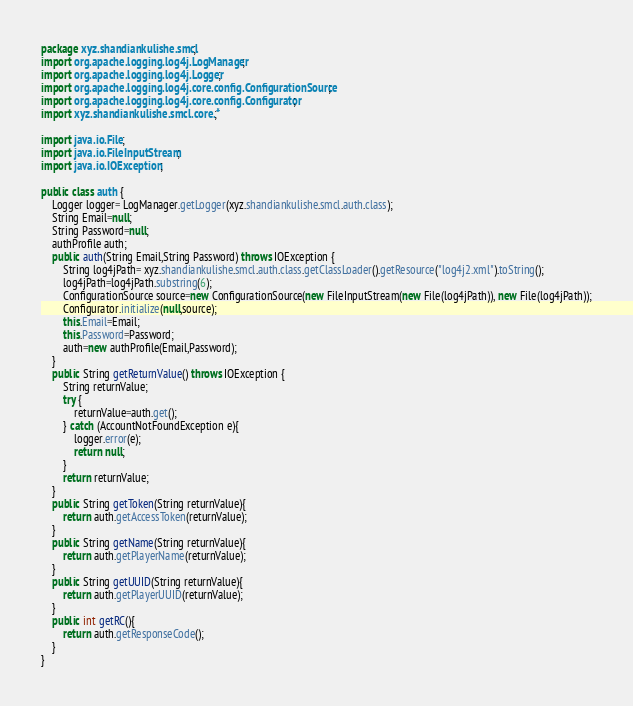<code> <loc_0><loc_0><loc_500><loc_500><_Java_>package xyz.shandiankulishe.smcl;
import org.apache.logging.log4j.LogManager;
import org.apache.logging.log4j.Logger;
import org.apache.logging.log4j.core.config.ConfigurationSource;
import org.apache.logging.log4j.core.config.Configurator;
import xyz.shandiankulishe.smcl.core.*;

import java.io.File;
import java.io.FileInputStream;
import java.io.IOException;

public class auth {
    Logger logger= LogManager.getLogger(xyz.shandiankulishe.smcl.auth.class);
    String Email=null;
    String Password=null;
    authProfile auth;
    public auth(String Email,String Password) throws IOException {
        String log4jPath= xyz.shandiankulishe.smcl.auth.class.getClassLoader().getResource("log4j2.xml").toString();
        log4jPath=log4jPath.substring(6);
        ConfigurationSource source=new ConfigurationSource(new FileInputStream(new File(log4jPath)), new File(log4jPath));
        Configurator.initialize(null,source);
        this.Email=Email;
        this.Password=Password;
        auth=new authProfile(Email,Password);
    }
    public String getReturnValue() throws IOException {
        String returnValue;
        try {
            returnValue=auth.get();
        } catch (AccountNotFoundException e){
            logger.error(e);
            return null;
        }
        return returnValue;
    }
    public String getToken(String returnValue){
        return auth.getAccessToken(returnValue);
    }
    public String getName(String returnValue){
        return auth.getPlayerName(returnValue);
    }
    public String getUUID(String returnValue){
        return auth.getPlayerUUID(returnValue);
    }
    public int getRC(){
        return auth.getResponseCode();
    }
}
</code> 